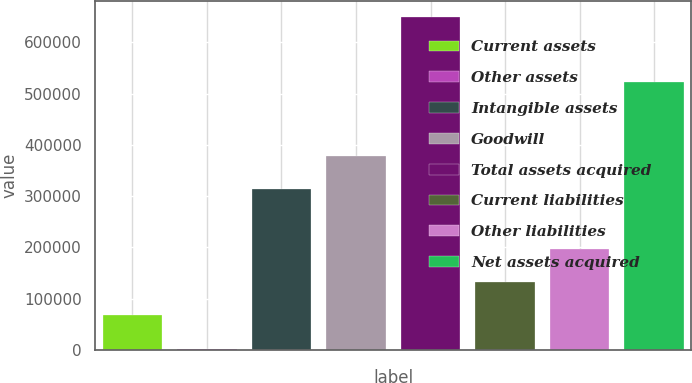<chart> <loc_0><loc_0><loc_500><loc_500><bar_chart><fcel>Current assets<fcel>Other assets<fcel>Intangible assets<fcel>Goodwill<fcel>Total assets acquired<fcel>Current liabilities<fcel>Other liabilities<fcel>Net assets acquired<nl><fcel>67565.1<fcel>2998<fcel>313600<fcel>378167<fcel>648669<fcel>132132<fcel>196699<fcel>522601<nl></chart> 